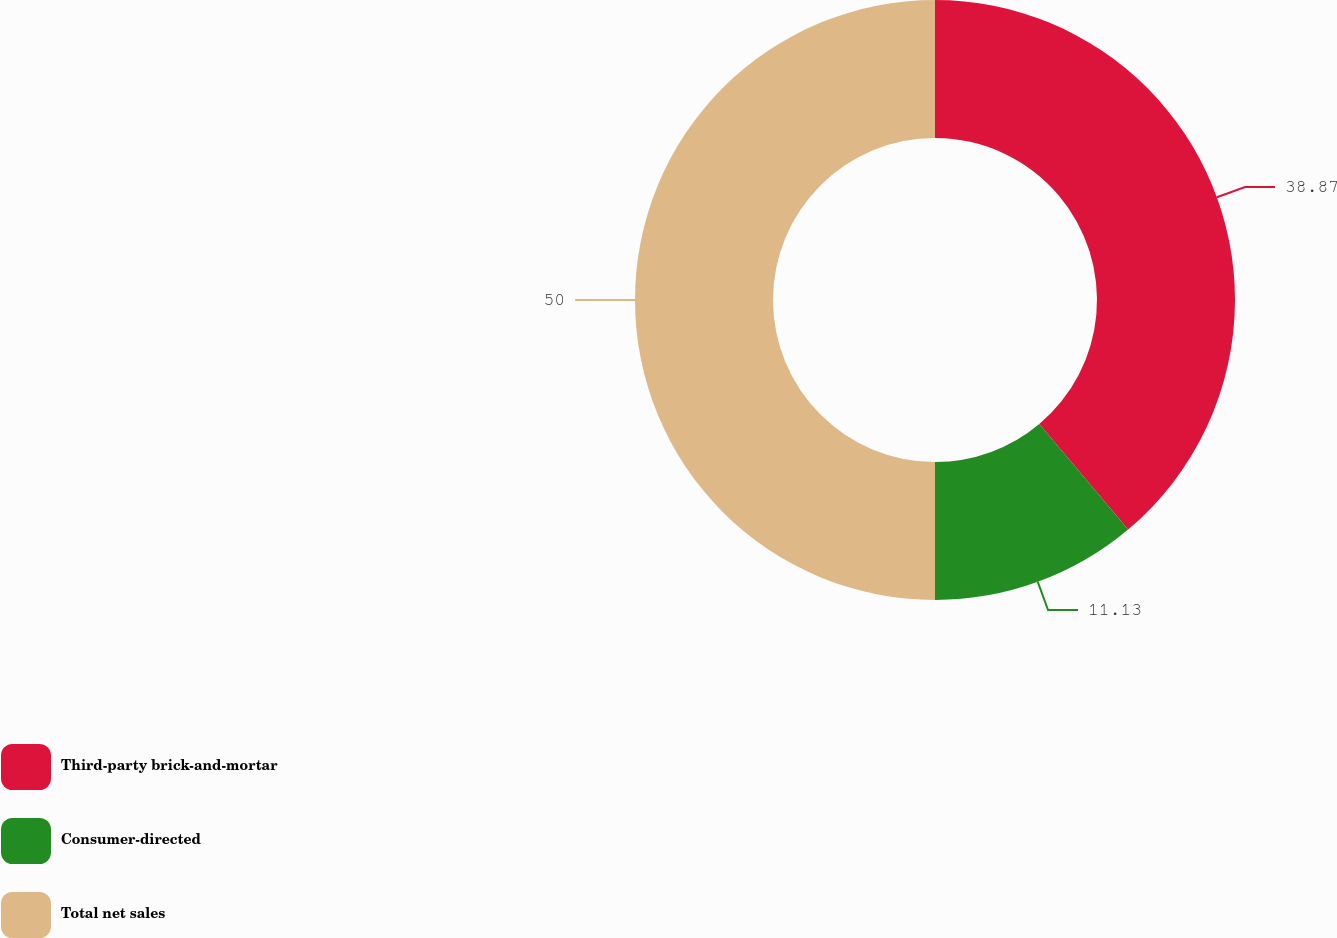Convert chart. <chart><loc_0><loc_0><loc_500><loc_500><pie_chart><fcel>Third-party brick-and-mortar<fcel>Consumer-directed<fcel>Total net sales<nl><fcel>38.87%<fcel>11.13%<fcel>50.0%<nl></chart> 